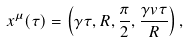Convert formula to latex. <formula><loc_0><loc_0><loc_500><loc_500>x ^ { \mu } ( \tau ) = \left ( \gamma \tau , R , \frac { \pi } { 2 } , \frac { \gamma v \tau } { R } \right ) ,</formula> 